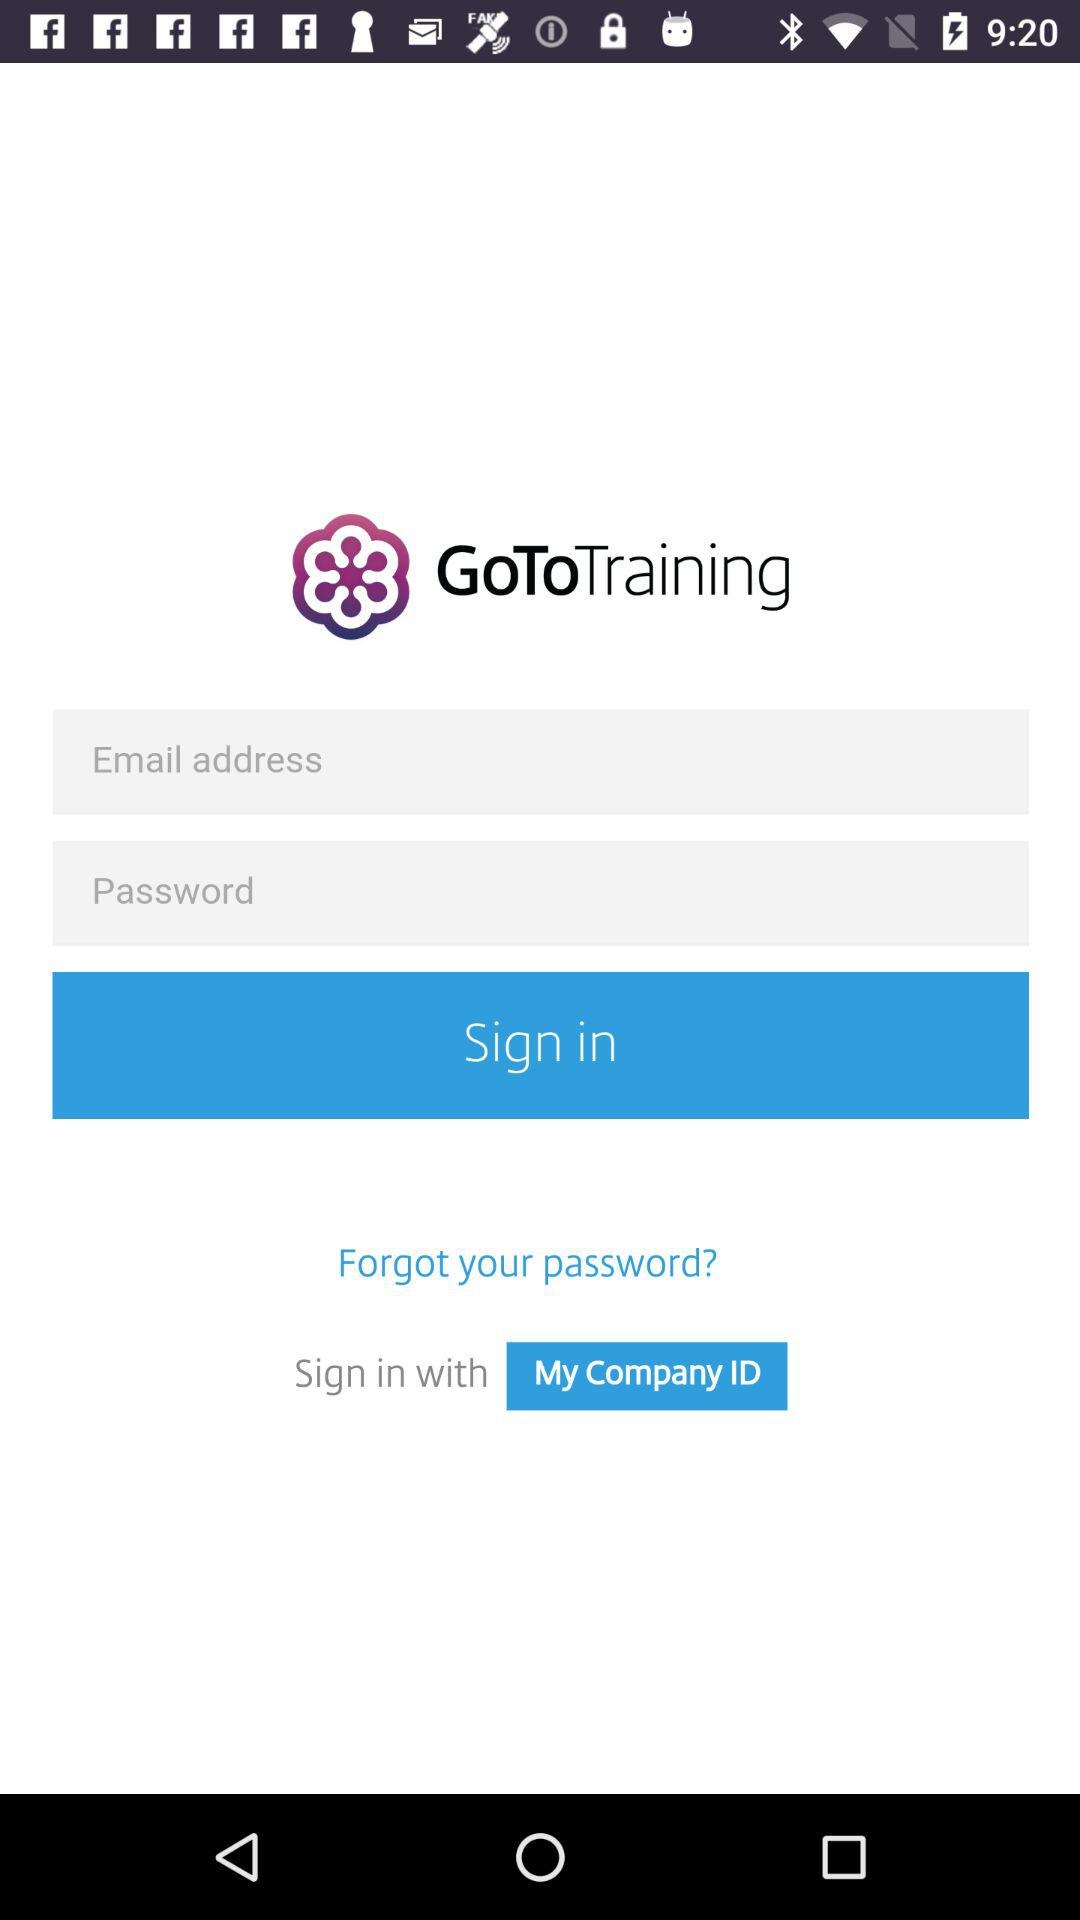What ID can I use to sign in? You can use "Company ID" to sign in. 